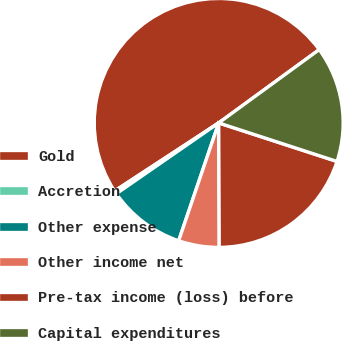Convert chart to OTSL. <chart><loc_0><loc_0><loc_500><loc_500><pie_chart><fcel>Gold<fcel>Accretion<fcel>Other expense<fcel>Other income net<fcel>Pre-tax income (loss) before<fcel>Capital expenditures<nl><fcel>49.19%<fcel>0.41%<fcel>10.16%<fcel>5.28%<fcel>19.92%<fcel>15.04%<nl></chart> 